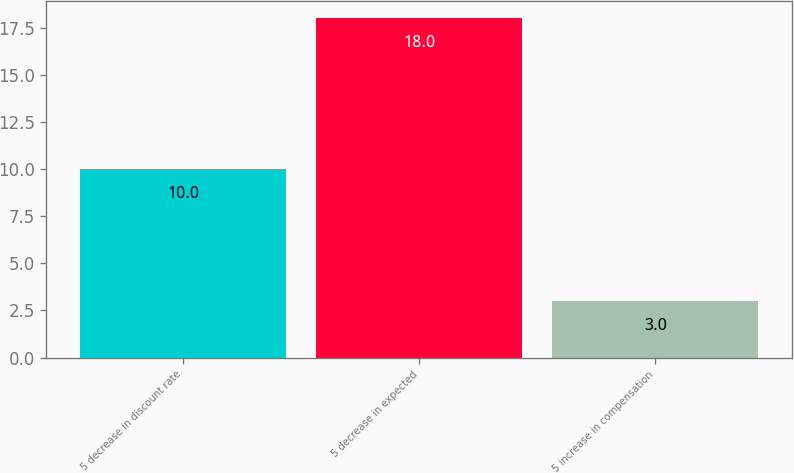<chart> <loc_0><loc_0><loc_500><loc_500><bar_chart><fcel>5 decrease in discount rate<fcel>5 decrease in expected<fcel>5 increase in compensation<nl><fcel>10<fcel>18<fcel>3<nl></chart> 